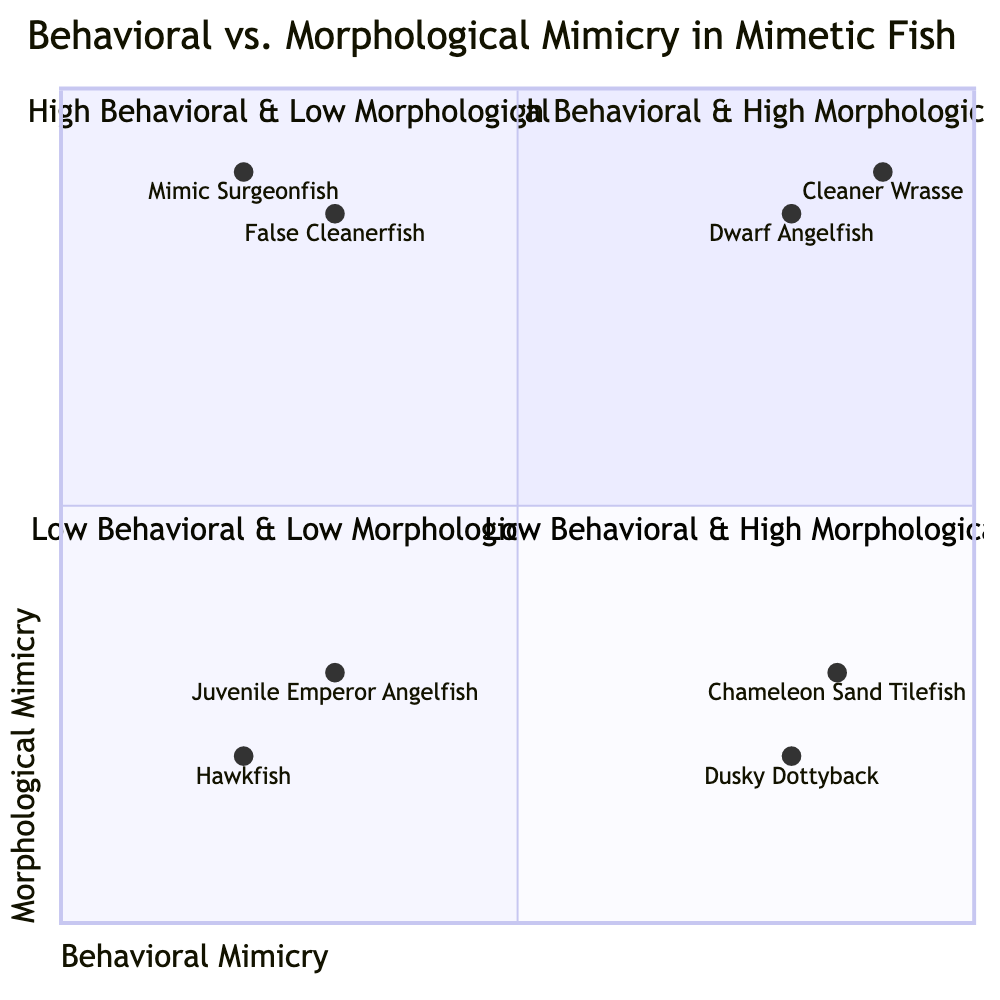What are the two examples in the High Behavioral & High Morphological quadrant? The High Behavioral & High Morphological quadrant includes the Cleaner Wrasse and Dwarf Angelfish as examples.
Answer: Cleaner Wrasse, Dwarf Angelfish How many species are in the Low Behavioral & Low Morphological quadrant? The Low Behavioral & Low Morphological quadrant contains two species: Juvenile Emperor Angelfish and some Hawkfish species.
Answer: 2 Which species has High Behavioral & Low Morphological mimicry? The Chameleon Sand Tilefish and Dusky Dottyback are examples of species that exhibit High Behavioral & Low Morphological mimicry.
Answer: Chameleon Sand Tilefish, Dusky Dottyback What is the primary characteristic of species in the Low Behavioral & High Morphological quadrant? Species in the Low Behavioral & High Morphological quadrant are structurally very similar to other species but do not exhibit the same behavioral patterns.
Answer: Similar structure, different behavior Which quadrant contains the False Cleanerfish? The False Cleanerfish appears in both the High Morphological quadrant as it has a high morphological mimicry and in relation to other species, as it is also linked with behavioral mimicry.
Answer: Low Behavioral & High Morphological, High Behavioral & High Morphological What characteristic distinguishes species in the High Behavioral & Low Morphological quadrant? Species in this quadrant rely primarily on behavioral mimicry, such as mimicking movements or habits, rather than on physical appearance.
Answer: Behavioral mimicry, not appearance 